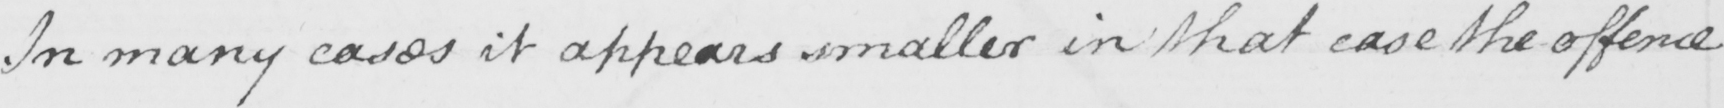What does this handwritten line say? In many cases it appears smaller in that case the offence 